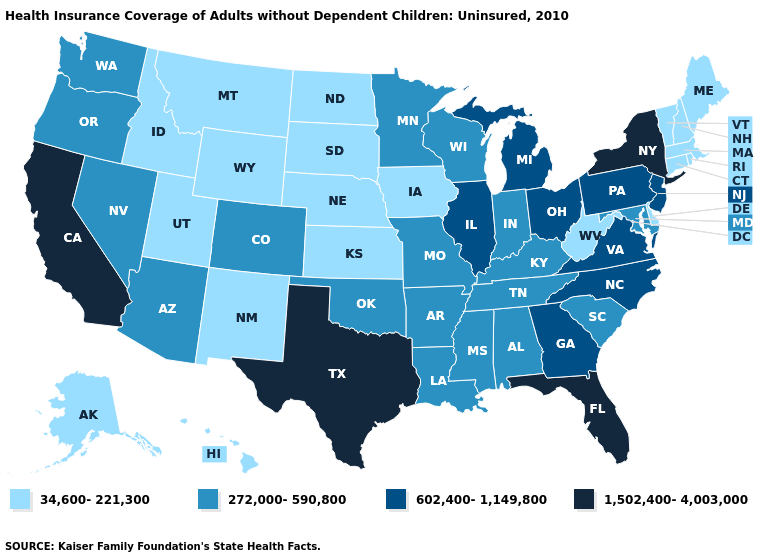Among the states that border West Virginia , does Kentucky have the lowest value?
Write a very short answer. Yes. Name the states that have a value in the range 272,000-590,800?
Give a very brief answer. Alabama, Arizona, Arkansas, Colorado, Indiana, Kentucky, Louisiana, Maryland, Minnesota, Mississippi, Missouri, Nevada, Oklahoma, Oregon, South Carolina, Tennessee, Washington, Wisconsin. Does Minnesota have the same value as Virginia?
Give a very brief answer. No. Name the states that have a value in the range 1,502,400-4,003,000?
Be succinct. California, Florida, New York, Texas. How many symbols are there in the legend?
Quick response, please. 4. Among the states that border New Mexico , which have the lowest value?
Write a very short answer. Utah. Name the states that have a value in the range 1,502,400-4,003,000?
Keep it brief. California, Florida, New York, Texas. Does Alabama have a higher value than Iowa?
Short answer required. Yes. Which states have the highest value in the USA?
Be succinct. California, Florida, New York, Texas. What is the lowest value in the USA?
Give a very brief answer. 34,600-221,300. Does California have the highest value in the USA?
Keep it brief. Yes. Name the states that have a value in the range 272,000-590,800?
Answer briefly. Alabama, Arizona, Arkansas, Colorado, Indiana, Kentucky, Louisiana, Maryland, Minnesota, Mississippi, Missouri, Nevada, Oklahoma, Oregon, South Carolina, Tennessee, Washington, Wisconsin. Among the states that border Minnesota , does Iowa have the highest value?
Write a very short answer. No. What is the lowest value in the USA?
Write a very short answer. 34,600-221,300. Does the first symbol in the legend represent the smallest category?
Quick response, please. Yes. 